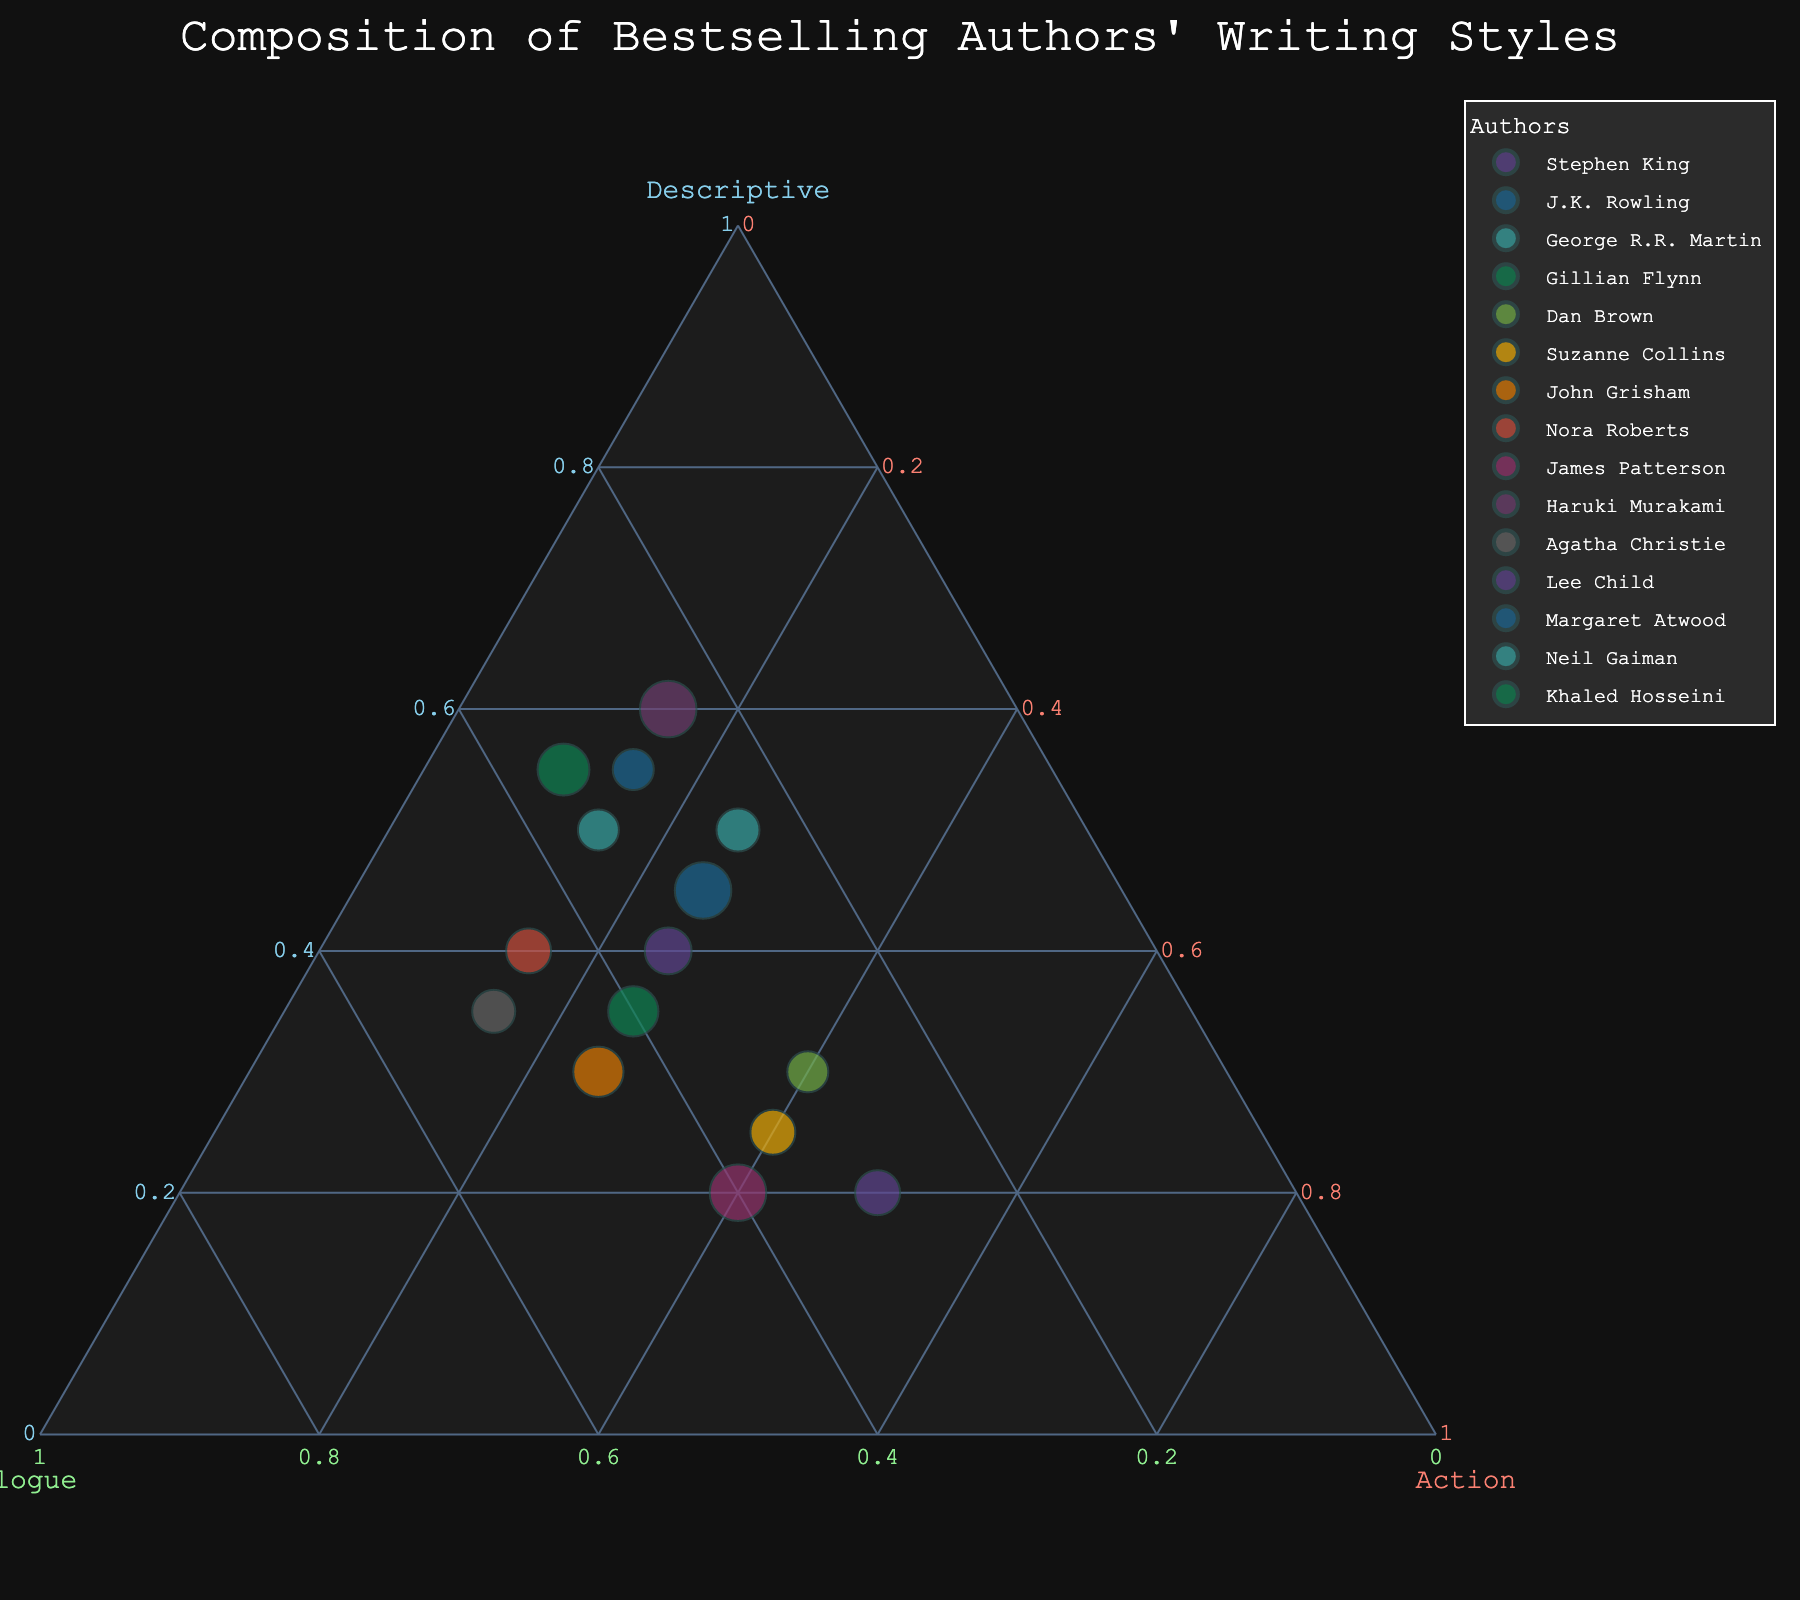What is the title of the plot? The title of the plot is usually found at the top and serves to describe the main topic of the figure. From the code, we see that the title is "Composition of Bestselling Authors' Writing Styles".
Answer: Composition of Bestselling Authors' Writing Styles Which author is associated with the point closest to the "Descriptive" apex? The apex points of a ternary plot represent the highest value for each component. From the data, Haruki Murakami and Khaled Hosseini both have the highest "Descriptive" value of 60 and 55 respectively. However, Haruki Murakami is the closest to the "Descriptive".
Answer: Haruki Murakami How many authors have "Action" as their most dominant writing style? By looking at the plot, we can see which authors lie closer to the "Action" apex. From the data, only Dan Brown, Suzanne Collins, James Patterson, and Lee Child have Action as their leading element. Hence, they form the group.
Answer: 4 What is the median value of the "Dialogue" component among all authors? To find the median, we first list all "Dialogue" values and order them: 25, 25, 25, 25, 30, 30, 30, 35, 35, 35, 40, 40, 45, 45, 50. Since we have 15 values, the median (middle value) is the 8th value, which is 35.
Answer: 35 Which author has the most balanced (equal or nearly equal) composition of all three writing styles? A balanced composition would mean that the author's data point is near the center of the ternary plot. From the data, Dan Brown and James Patterson have very close proportions to 30, 30, 40, but Dan Brown's exact values are the closest to being balanced.
Answer: Dan Brown Who has a higher percentage of "Dialogue", J.K. Rowling or Gillian Flynn? By comparing the "Dialogue" component of J.K. Rowling (30%) with Gillian Flynn (40%), it's clear that Gillian Flynn has the higher percentage.
Answer: Gillian Flynn Which authors have a lower percentage of "Descriptive" elements compared to their "Dialogue" elements? We compare "Descriptive" and "Dialogue" values for each author. Authors with lower "Descriptive" compared to "Dialogue" are Gillian Flynn (35 < 40), John Grisham (30 < 45), Nora Roberts (40 < 45), and Agatha Christie (35 < 50).
Answer: Gillian Flynn, John Grisham, Nora Roberts, Agatha Christie What is the sum of percentages for "Action" for Suzanne Collins and Lee Child combined? Suzanne Collins has 40% "Action", and Lee Child has 50%. Adding these values gives 40 + 50 = 90.
Answer: 90% 